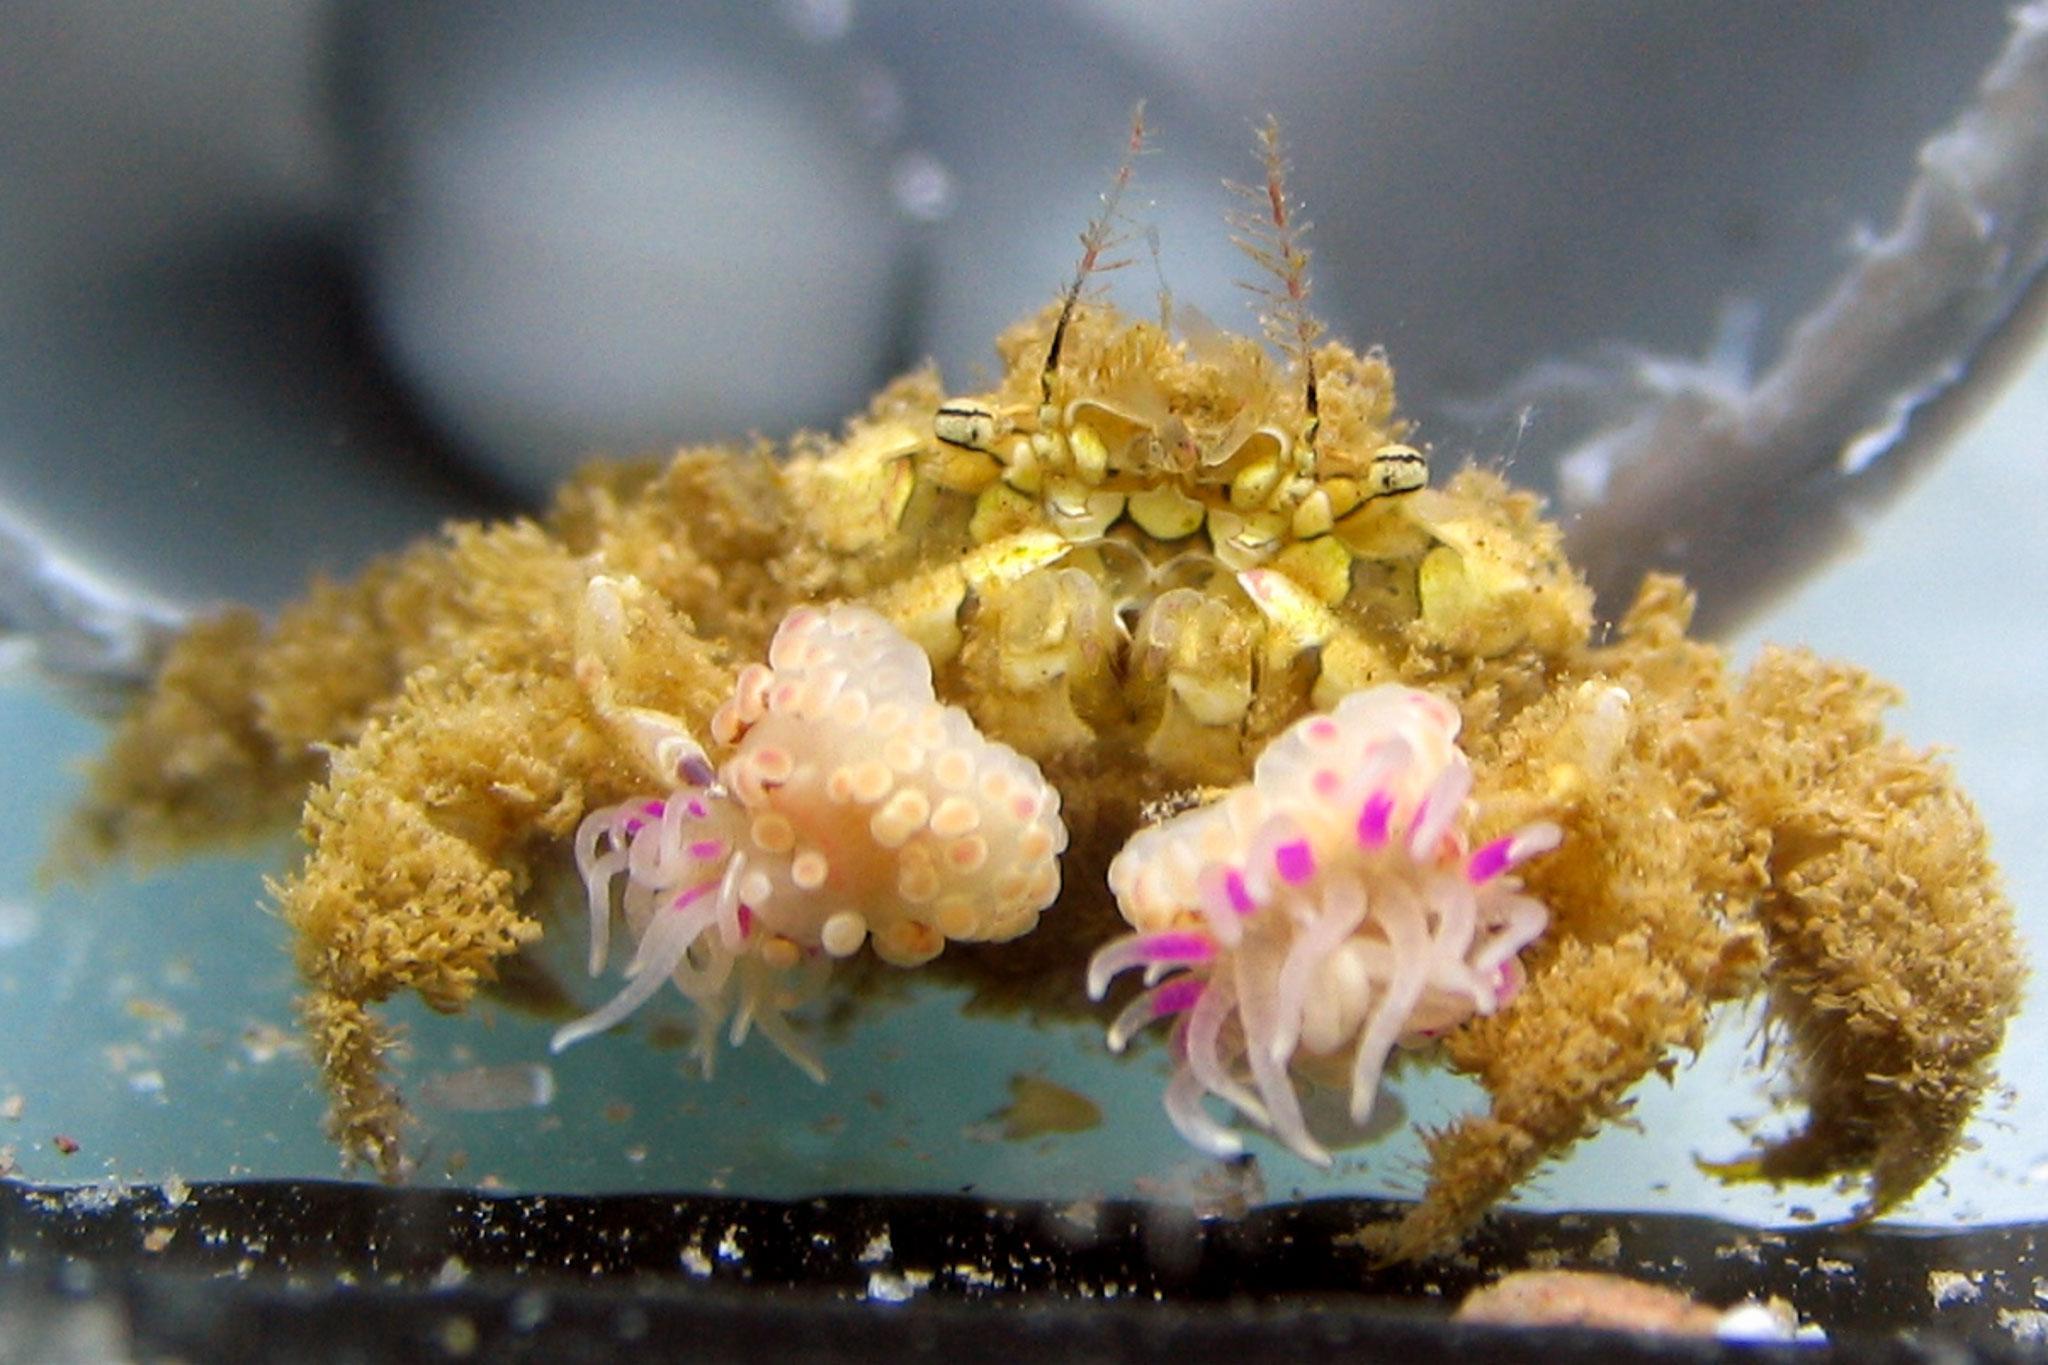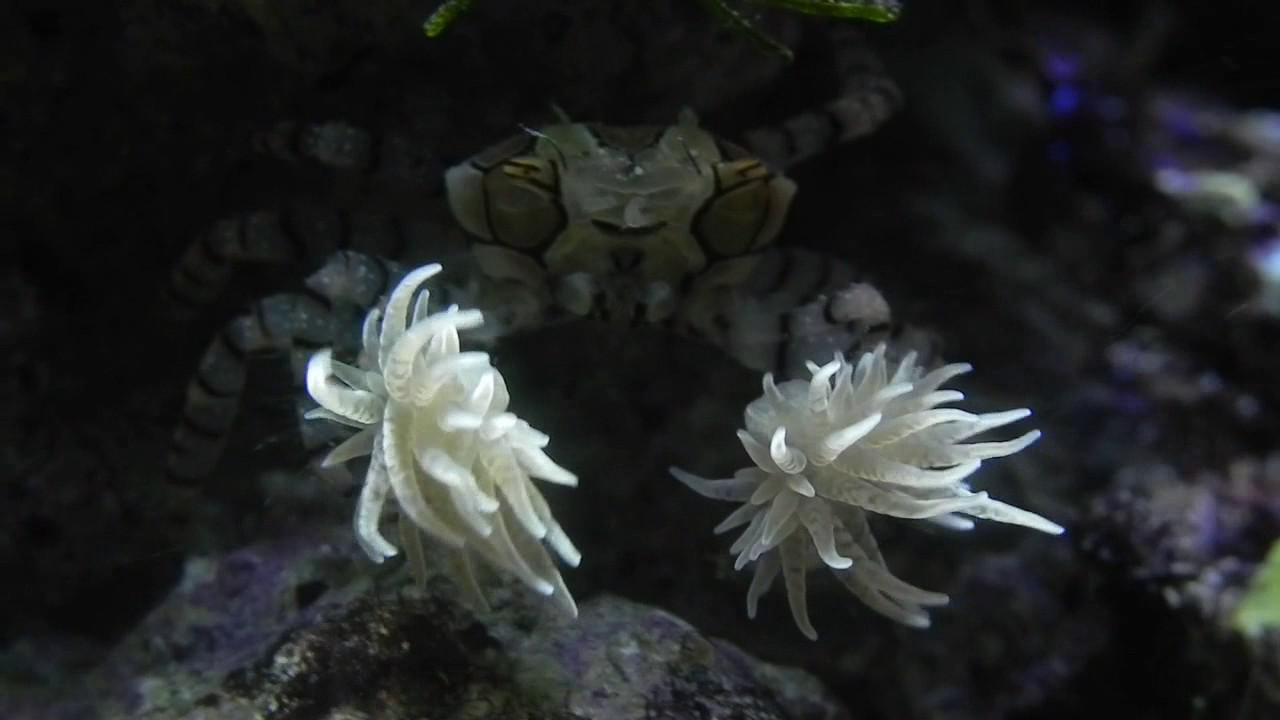The first image is the image on the left, the second image is the image on the right. Examine the images to the left and right. Is the description "There are two anemones in the image on the right." accurate? Answer yes or no. Yes. The first image is the image on the left, the second image is the image on the right. Examine the images to the left and right. Is the description "Right image shows two flower-shaped anemones." accurate? Answer yes or no. Yes. 